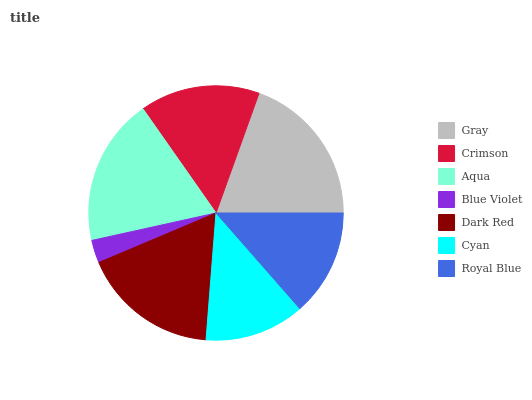Is Blue Violet the minimum?
Answer yes or no. Yes. Is Gray the maximum?
Answer yes or no. Yes. Is Crimson the minimum?
Answer yes or no. No. Is Crimson the maximum?
Answer yes or no. No. Is Gray greater than Crimson?
Answer yes or no. Yes. Is Crimson less than Gray?
Answer yes or no. Yes. Is Crimson greater than Gray?
Answer yes or no. No. Is Gray less than Crimson?
Answer yes or no. No. Is Crimson the high median?
Answer yes or no. Yes. Is Crimson the low median?
Answer yes or no. Yes. Is Blue Violet the high median?
Answer yes or no. No. Is Dark Red the low median?
Answer yes or no. No. 